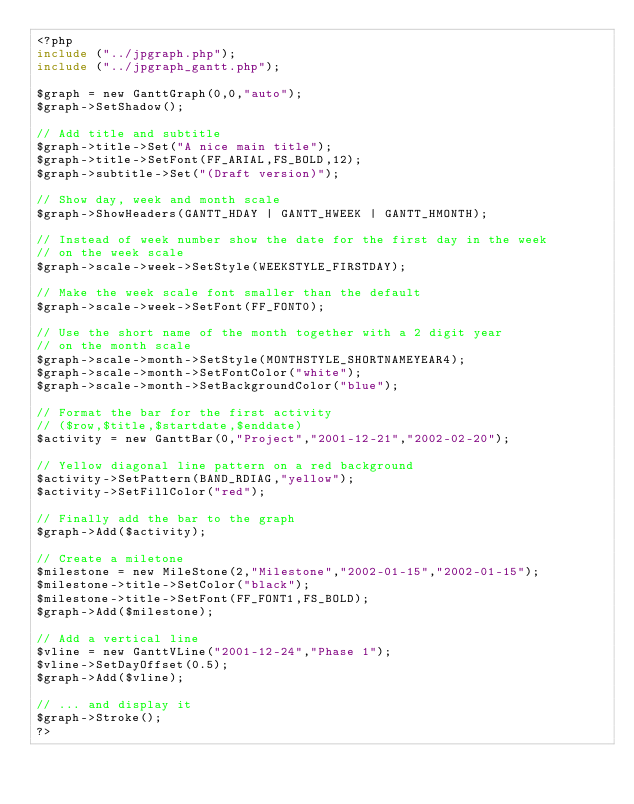<code> <loc_0><loc_0><loc_500><loc_500><_PHP_><?php
include ("../jpgraph.php");
include ("../jpgraph_gantt.php");

$graph = new GanttGraph(0,0,"auto");
$graph->SetShadow();

// Add title and subtitle
$graph->title->Set("A nice main title");
$graph->title->SetFont(FF_ARIAL,FS_BOLD,12);
$graph->subtitle->Set("(Draft version)");

// Show day, week and month scale
$graph->ShowHeaders(GANTT_HDAY | GANTT_HWEEK | GANTT_HMONTH);

// Instead of week number show the date for the first day in the week
// on the week scale
$graph->scale->week->SetStyle(WEEKSTYLE_FIRSTDAY);

// Make the week scale font smaller than the default
$graph->scale->week->SetFont(FF_FONT0);

// Use the short name of the month together with a 2 digit year
// on the month scale
$graph->scale->month->SetStyle(MONTHSTYLE_SHORTNAMEYEAR4);
$graph->scale->month->SetFontColor("white");
$graph->scale->month->SetBackgroundColor("blue");

// Format the bar for the first activity
// ($row,$title,$startdate,$enddate)
$activity = new GanttBar(0,"Project","2001-12-21","2002-02-20");

// Yellow diagonal line pattern on a red background
$activity->SetPattern(BAND_RDIAG,"yellow");
$activity->SetFillColor("red");

// Finally add the bar to the graph
$graph->Add($activity);

// Create a miletone
$milestone = new MileStone(2,"Milestone","2002-01-15","2002-01-15");
$milestone->title->SetColor("black");
$milestone->title->SetFont(FF_FONT1,FS_BOLD);
$graph->Add($milestone);

// Add a vertical line
$vline = new GanttVLine("2001-12-24","Phase 1");
$vline->SetDayOffset(0.5);
$graph->Add($vline);

// ... and display it
$graph->Stroke();
?>
</code> 